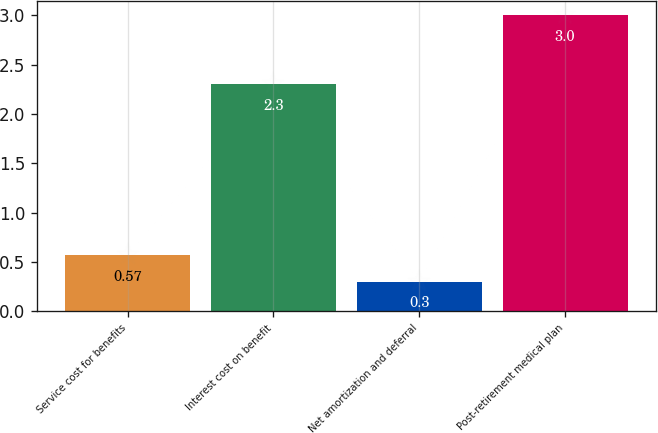<chart> <loc_0><loc_0><loc_500><loc_500><bar_chart><fcel>Service cost for benefits<fcel>Interest cost on benefit<fcel>Net amortization and deferral<fcel>Post-retirement medical plan<nl><fcel>0.57<fcel>2.3<fcel>0.3<fcel>3<nl></chart> 